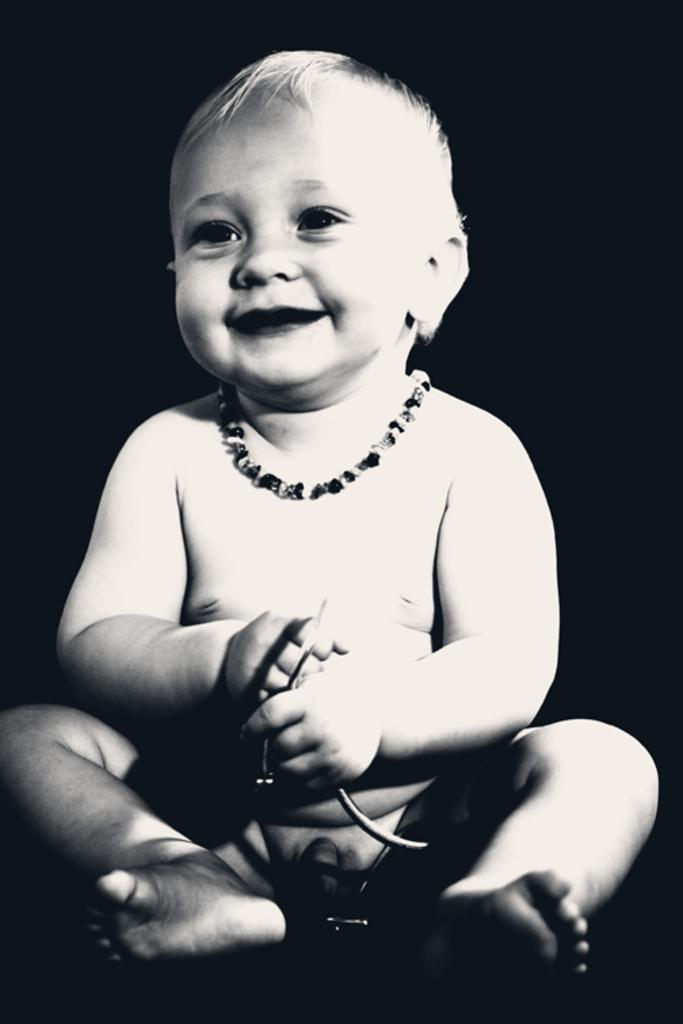What is the color scheme of the image? The image is black and white. What can be seen in the image? There is a kid in the image. Where is the kid located in the image? The kid is sitting on the floor. What year is the deer celebrating in the image? There is no deer present in the image, and therefore no celebration can be observed. 